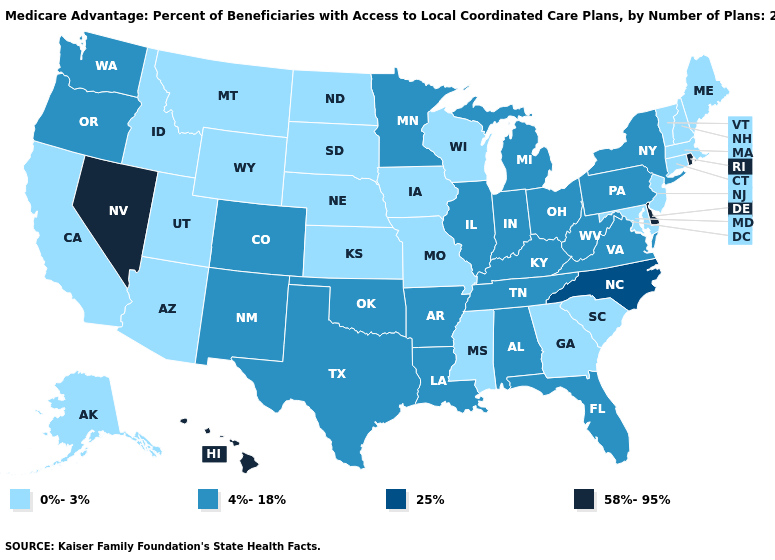What is the value of Maryland?
Quick response, please. 0%-3%. How many symbols are there in the legend?
Give a very brief answer. 4. Does Virginia have the lowest value in the USA?
Keep it brief. No. What is the value of California?
Short answer required. 0%-3%. Among the states that border Oregon , which have the highest value?
Give a very brief answer. Nevada. Name the states that have a value in the range 25%?
Concise answer only. North Carolina. Among the states that border New Mexico , which have the lowest value?
Write a very short answer. Arizona, Utah. Is the legend a continuous bar?
Short answer required. No. What is the value of Washington?
Answer briefly. 4%-18%. What is the highest value in the West ?
Quick response, please. 58%-95%. Which states have the lowest value in the USA?
Answer briefly. Alaska, Arizona, California, Connecticut, Georgia, Iowa, Idaho, Kansas, Massachusetts, Maryland, Maine, Missouri, Mississippi, Montana, North Dakota, Nebraska, New Hampshire, New Jersey, South Carolina, South Dakota, Utah, Vermont, Wisconsin, Wyoming. Does Montana have the lowest value in the USA?
Keep it brief. Yes. Name the states that have a value in the range 0%-3%?
Write a very short answer. Alaska, Arizona, California, Connecticut, Georgia, Iowa, Idaho, Kansas, Massachusetts, Maryland, Maine, Missouri, Mississippi, Montana, North Dakota, Nebraska, New Hampshire, New Jersey, South Carolina, South Dakota, Utah, Vermont, Wisconsin, Wyoming. Among the states that border Virginia , does Kentucky have the highest value?
Quick response, please. No. Among the states that border Washington , which have the highest value?
Write a very short answer. Oregon. 